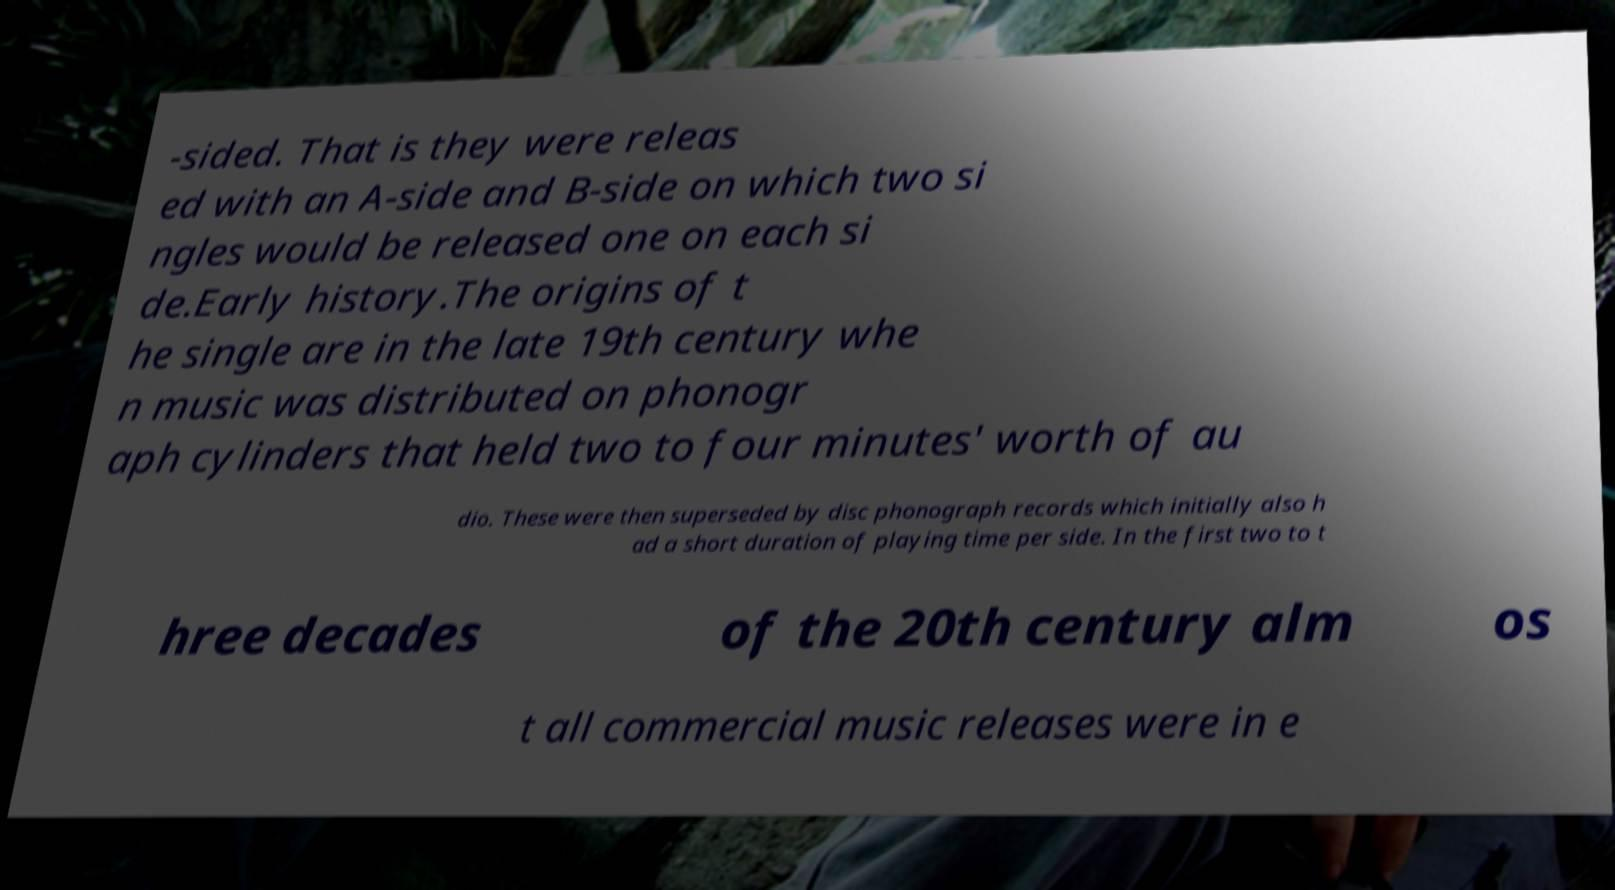Please read and relay the text visible in this image. What does it say? -sided. That is they were releas ed with an A-side and B-side on which two si ngles would be released one on each si de.Early history.The origins of t he single are in the late 19th century whe n music was distributed on phonogr aph cylinders that held two to four minutes' worth of au dio. These were then superseded by disc phonograph records which initially also h ad a short duration of playing time per side. In the first two to t hree decades of the 20th century alm os t all commercial music releases were in e 